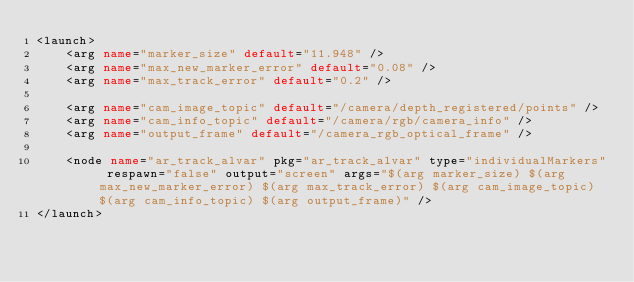<code> <loc_0><loc_0><loc_500><loc_500><_XML_><launch>
	<arg name="marker_size" default="11.948" />
	<arg name="max_new_marker_error" default="0.08" />
	<arg name="max_track_error" default="0.2" />

	<arg name="cam_image_topic" default="/camera/depth_registered/points" />
	<arg name="cam_info_topic" default="/camera/rgb/camera_info" />		
	<arg name="output_frame" default="/camera_rgb_optical_frame" />

	<node name="ar_track_alvar" pkg="ar_track_alvar" type="individualMarkers" respawn="false" output="screen" args="$(arg marker_size) $(arg max_new_marker_error) $(arg max_track_error) $(arg cam_image_topic) $(arg cam_info_topic) $(arg output_frame)" />
</launch>
</code> 